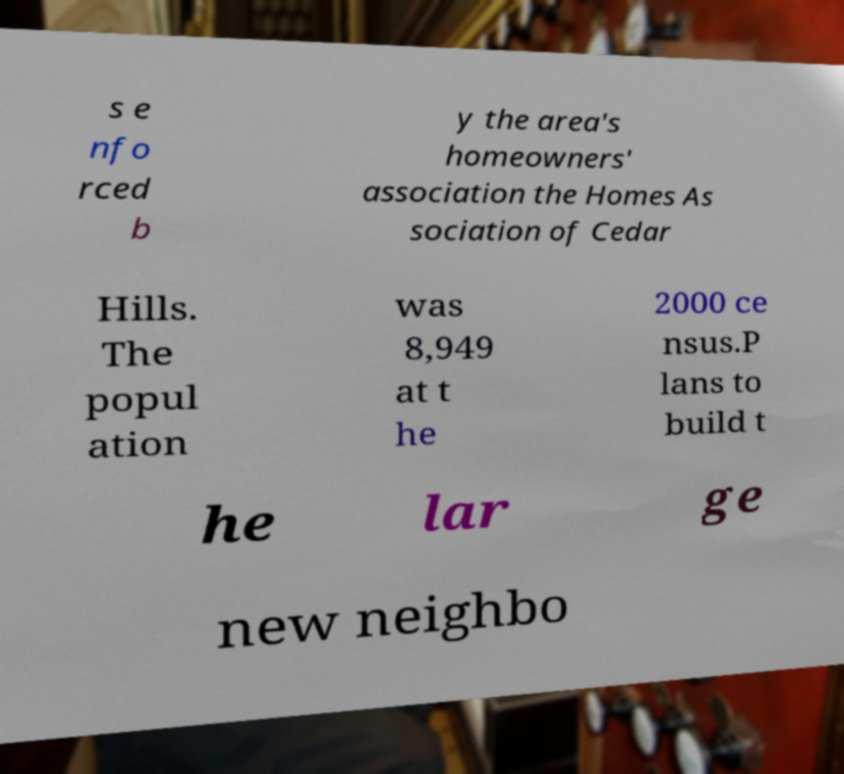There's text embedded in this image that I need extracted. Can you transcribe it verbatim? s e nfo rced b y the area's homeowners' association the Homes As sociation of Cedar Hills. The popul ation was 8,949 at t he 2000 ce nsus.P lans to build t he lar ge new neighbo 